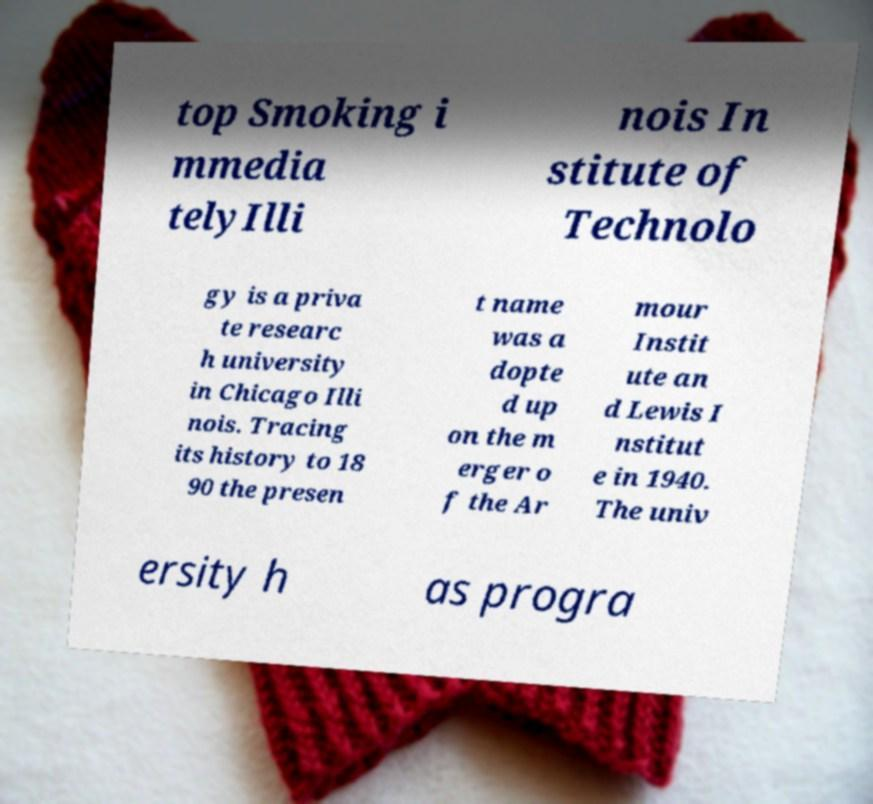Please read and relay the text visible in this image. What does it say? top Smoking i mmedia telyIlli nois In stitute of Technolo gy is a priva te researc h university in Chicago Illi nois. Tracing its history to 18 90 the presen t name was a dopte d up on the m erger o f the Ar mour Instit ute an d Lewis I nstitut e in 1940. The univ ersity h as progra 